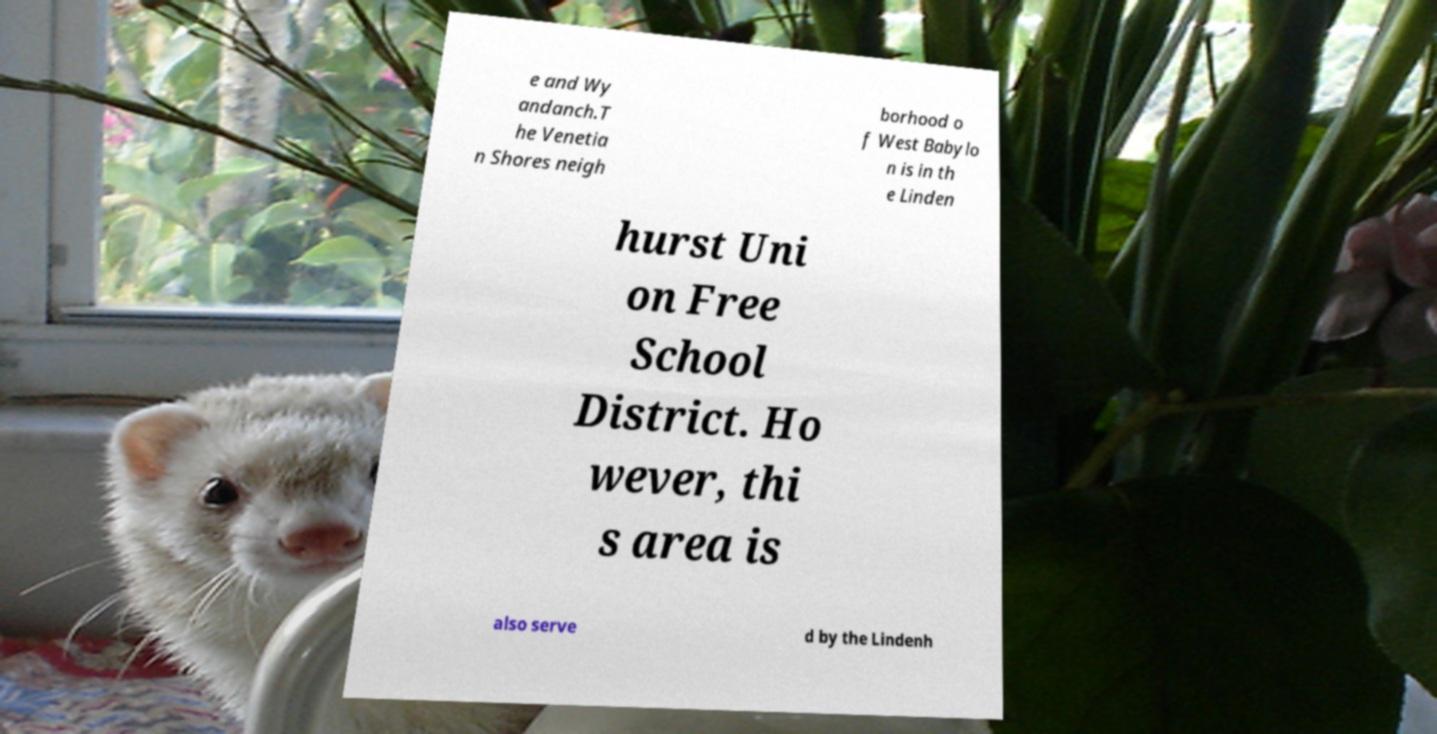Please identify and transcribe the text found in this image. e and Wy andanch.T he Venetia n Shores neigh borhood o f West Babylo n is in th e Linden hurst Uni on Free School District. Ho wever, thi s area is also serve d by the Lindenh 